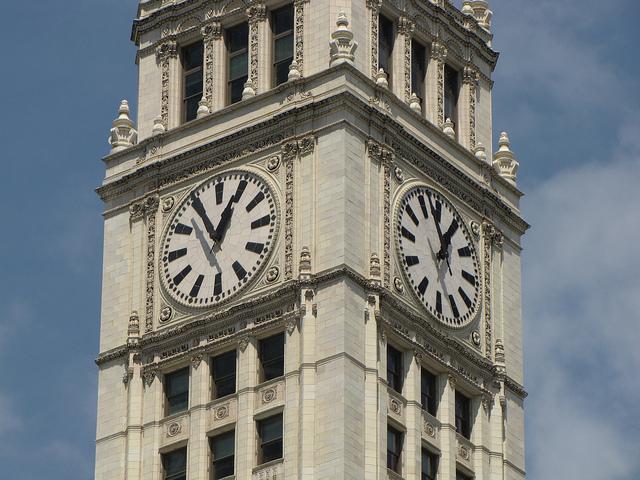Where is this picture taken?
Answer briefly. Outside. What time does the clock say it is?
Concise answer only. 12:55. Is this the Big Ben clock tower?
Quick response, please. Yes. Is this an old building?
Write a very short answer. Yes. What material is the building made of?
Quick response, please. Stone. What time is it?
Short answer required. 12:55. Are there shutters on the top of the clock?
Short answer required. No. Who works in this building?
Keep it brief. Unknown. 